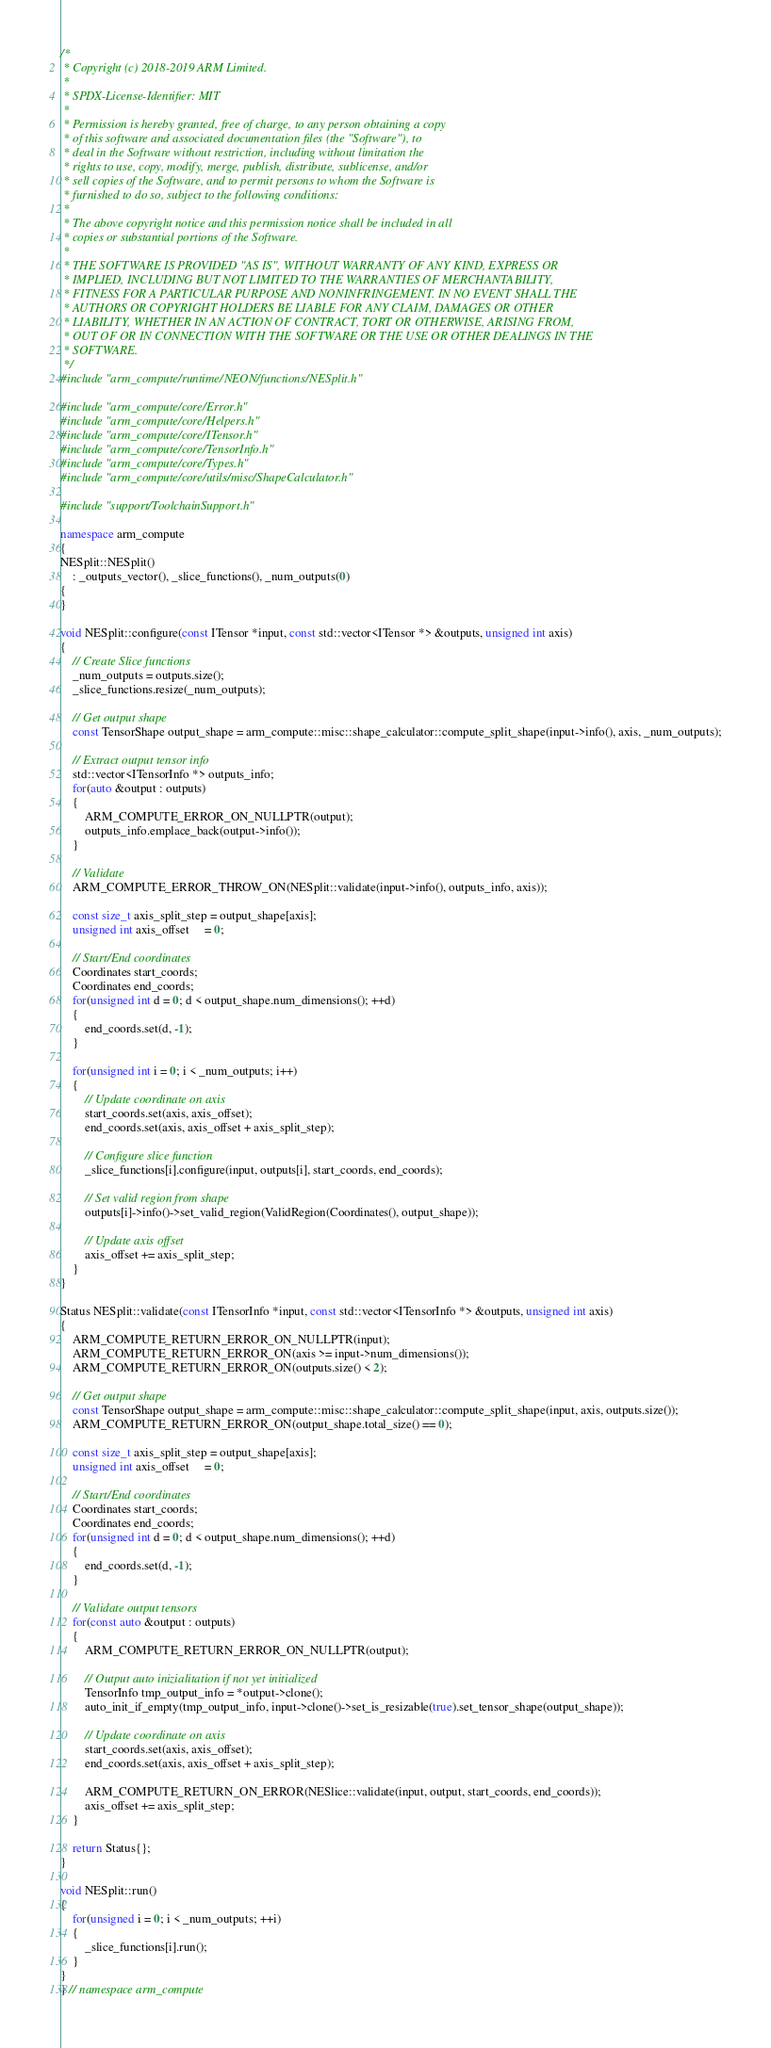Convert code to text. <code><loc_0><loc_0><loc_500><loc_500><_C++_>/*
 * Copyright (c) 2018-2019 ARM Limited.
 *
 * SPDX-License-Identifier: MIT
 *
 * Permission is hereby granted, free of charge, to any person obtaining a copy
 * of this software and associated documentation files (the "Software"), to
 * deal in the Software without restriction, including without limitation the
 * rights to use, copy, modify, merge, publish, distribute, sublicense, and/or
 * sell copies of the Software, and to permit persons to whom the Software is
 * furnished to do so, subject to the following conditions:
 *
 * The above copyright notice and this permission notice shall be included in all
 * copies or substantial portions of the Software.
 *
 * THE SOFTWARE IS PROVIDED "AS IS", WITHOUT WARRANTY OF ANY KIND, EXPRESS OR
 * IMPLIED, INCLUDING BUT NOT LIMITED TO THE WARRANTIES OF MERCHANTABILITY,
 * FITNESS FOR A PARTICULAR PURPOSE AND NONINFRINGEMENT. IN NO EVENT SHALL THE
 * AUTHORS OR COPYRIGHT HOLDERS BE LIABLE FOR ANY CLAIM, DAMAGES OR OTHER
 * LIABILITY, WHETHER IN AN ACTION OF CONTRACT, TORT OR OTHERWISE, ARISING FROM,
 * OUT OF OR IN CONNECTION WITH THE SOFTWARE OR THE USE OR OTHER DEALINGS IN THE
 * SOFTWARE.
 */
#include "arm_compute/runtime/NEON/functions/NESplit.h"

#include "arm_compute/core/Error.h"
#include "arm_compute/core/Helpers.h"
#include "arm_compute/core/ITensor.h"
#include "arm_compute/core/TensorInfo.h"
#include "arm_compute/core/Types.h"
#include "arm_compute/core/utils/misc/ShapeCalculator.h"

#include "support/ToolchainSupport.h"

namespace arm_compute
{
NESplit::NESplit()
    : _outputs_vector(), _slice_functions(), _num_outputs(0)
{
}

void NESplit::configure(const ITensor *input, const std::vector<ITensor *> &outputs, unsigned int axis)
{
    // Create Slice functions
    _num_outputs = outputs.size();
    _slice_functions.resize(_num_outputs);

    // Get output shape
    const TensorShape output_shape = arm_compute::misc::shape_calculator::compute_split_shape(input->info(), axis, _num_outputs);

    // Extract output tensor info
    std::vector<ITensorInfo *> outputs_info;
    for(auto &output : outputs)
    {
        ARM_COMPUTE_ERROR_ON_NULLPTR(output);
        outputs_info.emplace_back(output->info());
    }

    // Validate
    ARM_COMPUTE_ERROR_THROW_ON(NESplit::validate(input->info(), outputs_info, axis));

    const size_t axis_split_step = output_shape[axis];
    unsigned int axis_offset     = 0;

    // Start/End coordinates
    Coordinates start_coords;
    Coordinates end_coords;
    for(unsigned int d = 0; d < output_shape.num_dimensions(); ++d)
    {
        end_coords.set(d, -1);
    }

    for(unsigned int i = 0; i < _num_outputs; i++)
    {
        // Update coordinate on axis
        start_coords.set(axis, axis_offset);
        end_coords.set(axis, axis_offset + axis_split_step);

        // Configure slice function
        _slice_functions[i].configure(input, outputs[i], start_coords, end_coords);

        // Set valid region from shape
        outputs[i]->info()->set_valid_region(ValidRegion(Coordinates(), output_shape));

        // Update axis offset
        axis_offset += axis_split_step;
    }
}

Status NESplit::validate(const ITensorInfo *input, const std::vector<ITensorInfo *> &outputs, unsigned int axis)
{
    ARM_COMPUTE_RETURN_ERROR_ON_NULLPTR(input);
    ARM_COMPUTE_RETURN_ERROR_ON(axis >= input->num_dimensions());
    ARM_COMPUTE_RETURN_ERROR_ON(outputs.size() < 2);

    // Get output shape
    const TensorShape output_shape = arm_compute::misc::shape_calculator::compute_split_shape(input, axis, outputs.size());
    ARM_COMPUTE_RETURN_ERROR_ON(output_shape.total_size() == 0);

    const size_t axis_split_step = output_shape[axis];
    unsigned int axis_offset     = 0;

    // Start/End coordinates
    Coordinates start_coords;
    Coordinates end_coords;
    for(unsigned int d = 0; d < output_shape.num_dimensions(); ++d)
    {
        end_coords.set(d, -1);
    }

    // Validate output tensors
    for(const auto &output : outputs)
    {
        ARM_COMPUTE_RETURN_ERROR_ON_NULLPTR(output);

        // Output auto inizialitation if not yet initialized
        TensorInfo tmp_output_info = *output->clone();
        auto_init_if_empty(tmp_output_info, input->clone()->set_is_resizable(true).set_tensor_shape(output_shape));

        // Update coordinate on axis
        start_coords.set(axis, axis_offset);
        end_coords.set(axis, axis_offset + axis_split_step);

        ARM_COMPUTE_RETURN_ON_ERROR(NESlice::validate(input, output, start_coords, end_coords));
        axis_offset += axis_split_step;
    }

    return Status{};
}

void NESplit::run()
{
    for(unsigned i = 0; i < _num_outputs; ++i)
    {
        _slice_functions[i].run();
    }
}
} // namespace arm_compute
</code> 